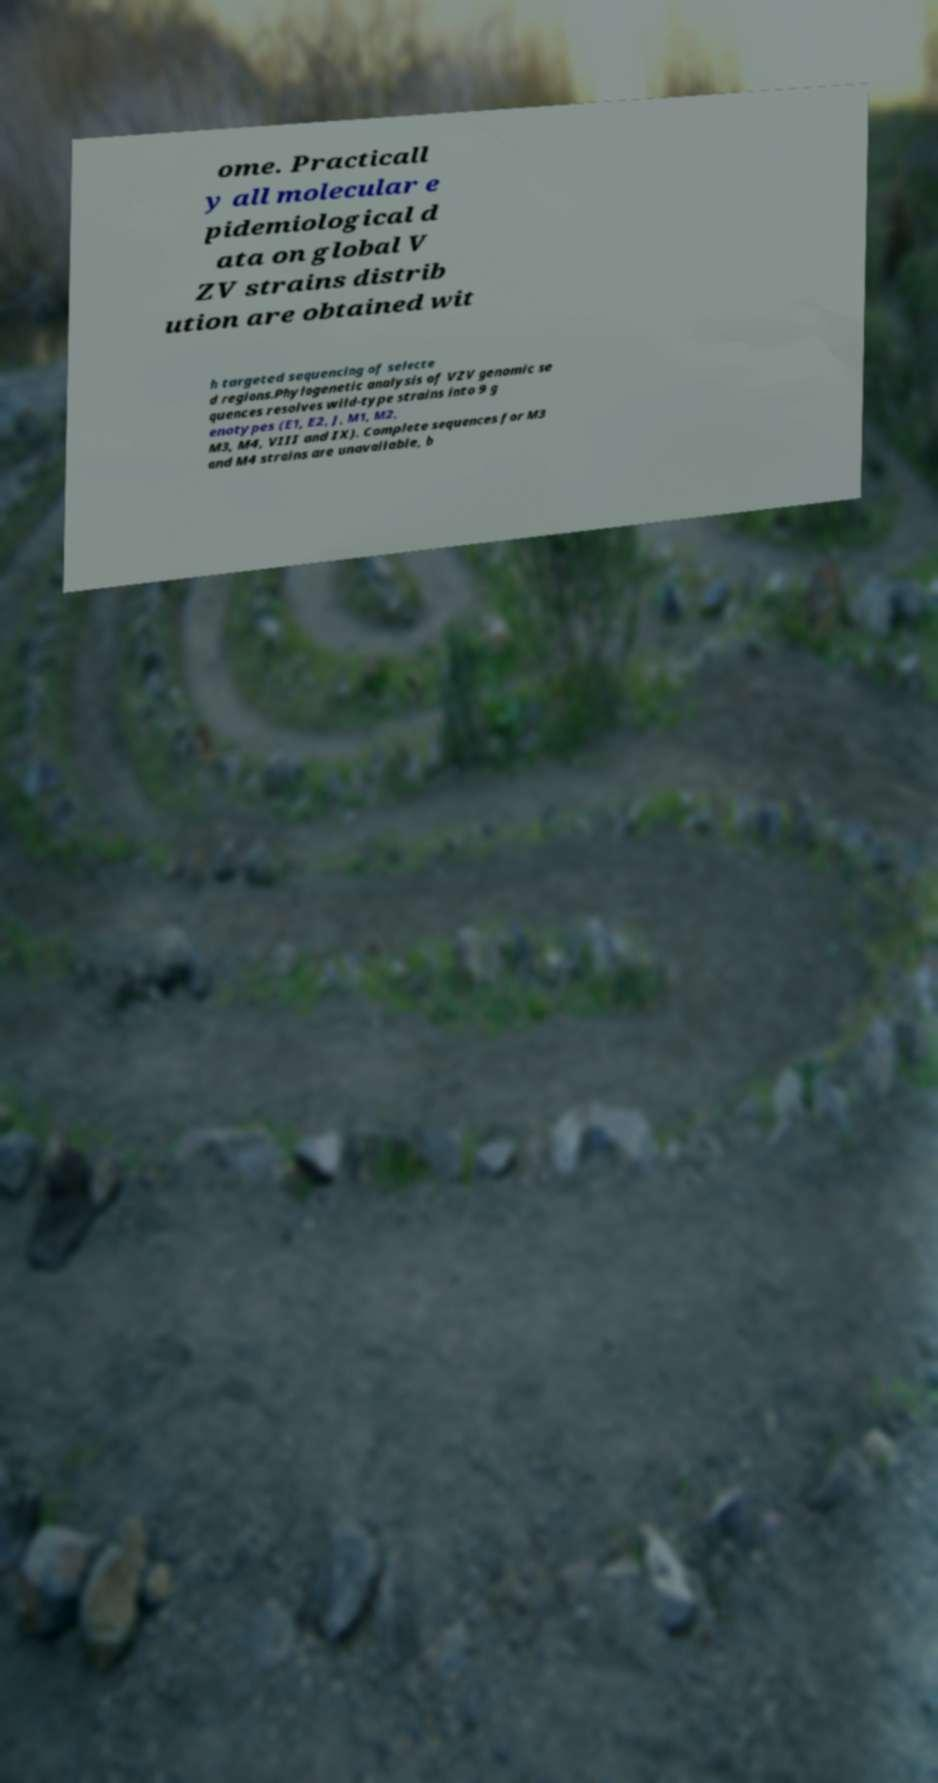For documentation purposes, I need the text within this image transcribed. Could you provide that? ome. Practicall y all molecular e pidemiological d ata on global V ZV strains distrib ution are obtained wit h targeted sequencing of selecte d regions.Phylogenetic analysis of VZV genomic se quences resolves wild-type strains into 9 g enotypes (E1, E2, J, M1, M2, M3, M4, VIII and IX). Complete sequences for M3 and M4 strains are unavailable, b 